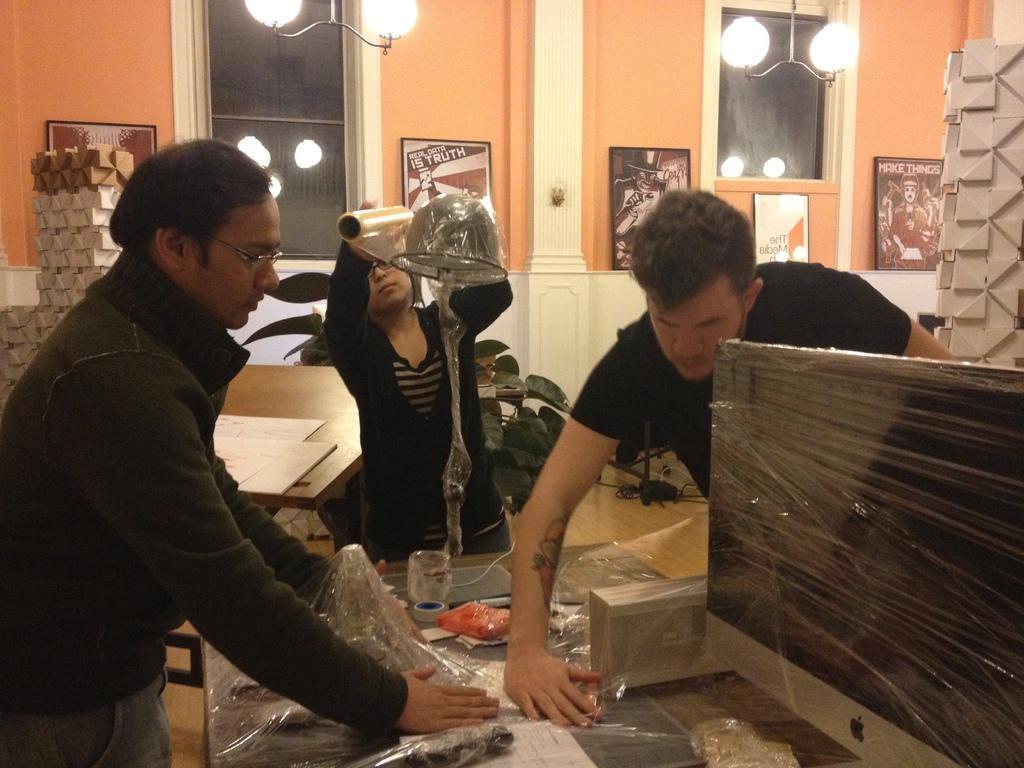Please provide a concise description of this image. In this image three persons who are standing on the left side there is one person who is standing is wearing spectacles and black shirt on the top of the image there is wall and lights are there and in the middle of the image there is one plant and table is there and on that table there are some papers and in the bottom of the image there is one table on that table there are some plastic covers, tape are there and in the bottom of the right corner there is one monitor. 